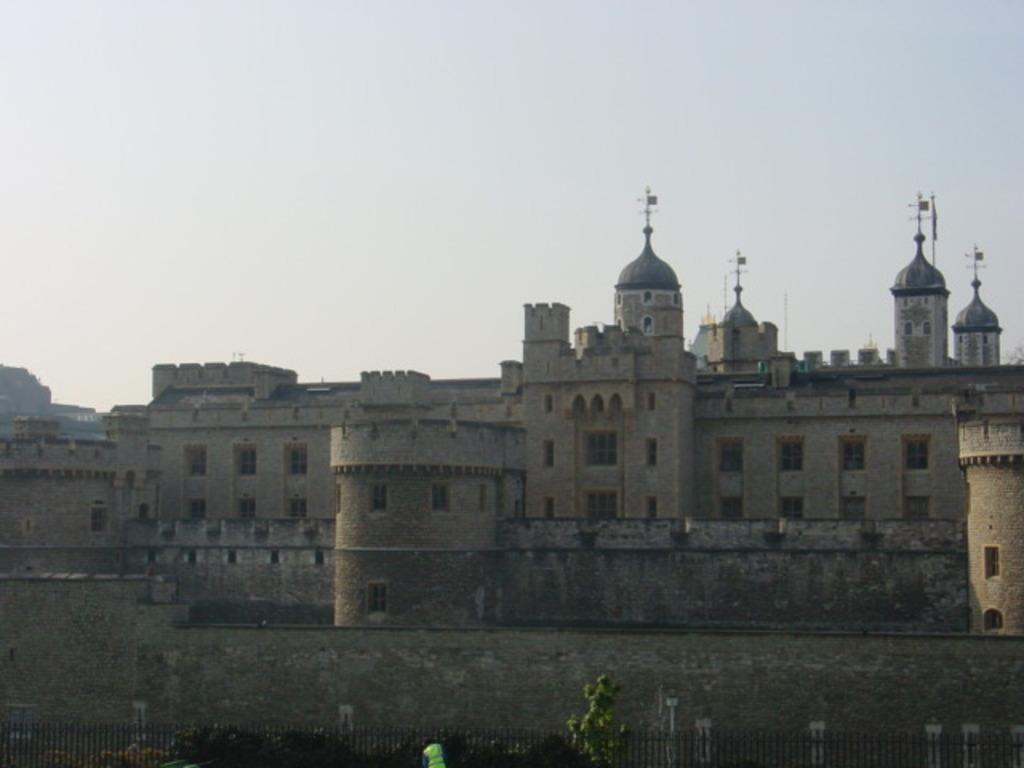What is the main structure in the middle of the image? There is a building in the middle of the image. What is located at the bottom of the image? There is fencing at the bottom of the image. What can be seen at the top of the image? The sky is visible at the top of the image. What type of cracker is being used to control the authority in the image? There is no cracker or authority present in the image. How does the throat of the building appear in the image? The image does not depict a building with a throat, as buildings do not have throats. 